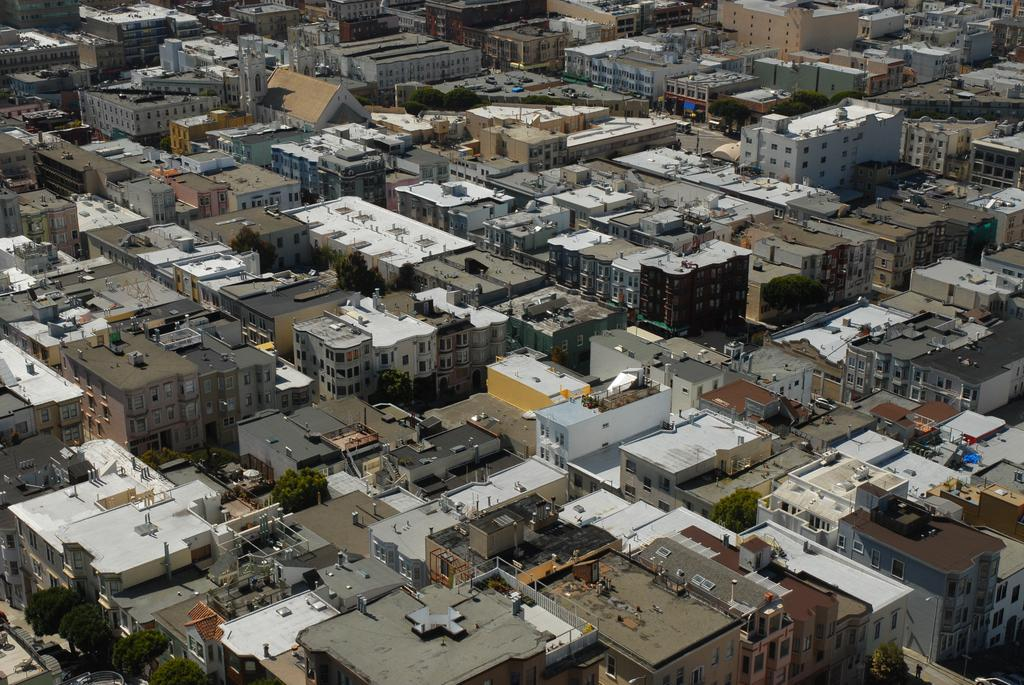What type of structures can be seen in the image? There are buildings in the image. What else is present in the image besides buildings? There is a road, trees, vehicles, and poles in the image. Can you describe the road in the image? The road is visible in the image. What type of vegetation is present in the image? There are trees in the image. What color is the hair on the trees in the image? There is no hair present on the trees in the image; they are covered with leaves or needles. Can you tell me how many suits are hanging on the poles in the image? There are no suits present in the image; the poles are likely utility poles or streetlights. 